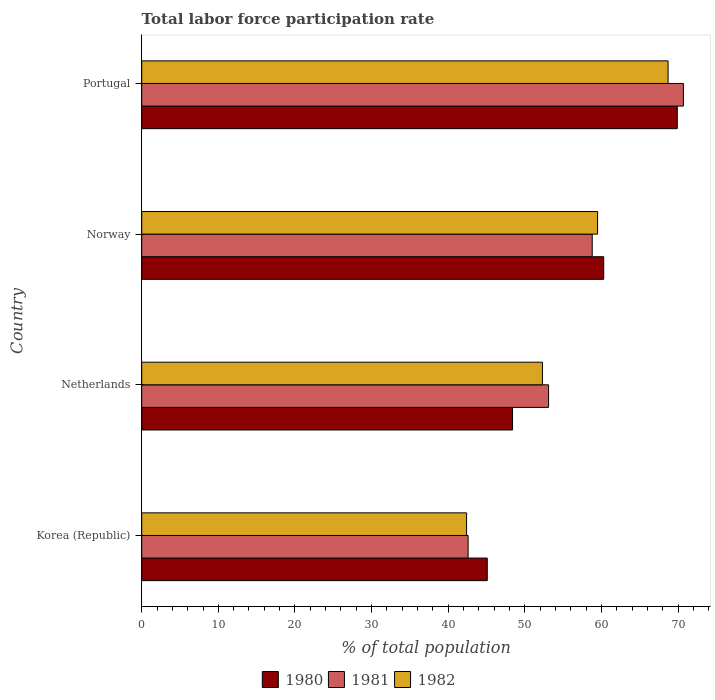Are the number of bars on each tick of the Y-axis equal?
Your answer should be compact. Yes. What is the label of the 4th group of bars from the top?
Your response must be concise. Korea (Republic). In how many cases, is the number of bars for a given country not equal to the number of legend labels?
Your answer should be very brief. 0. What is the total labor force participation rate in 1981 in Korea (Republic)?
Offer a very short reply. 42.6. Across all countries, what is the maximum total labor force participation rate in 1982?
Offer a very short reply. 68.7. Across all countries, what is the minimum total labor force participation rate in 1981?
Ensure brevity in your answer.  42.6. In which country was the total labor force participation rate in 1982 minimum?
Provide a succinct answer. Korea (Republic). What is the total total labor force participation rate in 1980 in the graph?
Your answer should be very brief. 223.7. What is the difference between the total labor force participation rate in 1982 in Norway and that in Portugal?
Keep it short and to the point. -9.2. What is the difference between the total labor force participation rate in 1982 in Netherlands and the total labor force participation rate in 1980 in Norway?
Make the answer very short. -8. What is the average total labor force participation rate in 1981 per country?
Give a very brief answer. 56.3. What is the difference between the total labor force participation rate in 1981 and total labor force participation rate in 1980 in Norway?
Your response must be concise. -1.5. In how many countries, is the total labor force participation rate in 1980 greater than 52 %?
Your response must be concise. 2. What is the ratio of the total labor force participation rate in 1981 in Korea (Republic) to that in Portugal?
Provide a succinct answer. 0.6. Is the total labor force participation rate in 1981 in Korea (Republic) less than that in Portugal?
Your answer should be very brief. Yes. What is the difference between the highest and the second highest total labor force participation rate in 1981?
Offer a very short reply. 11.9. What is the difference between the highest and the lowest total labor force participation rate in 1980?
Keep it short and to the point. 24.8. Is the sum of the total labor force participation rate in 1980 in Netherlands and Norway greater than the maximum total labor force participation rate in 1982 across all countries?
Ensure brevity in your answer.  Yes. Is it the case that in every country, the sum of the total labor force participation rate in 1980 and total labor force participation rate in 1982 is greater than the total labor force participation rate in 1981?
Ensure brevity in your answer.  Yes. How many countries are there in the graph?
Ensure brevity in your answer.  4. What is the difference between two consecutive major ticks on the X-axis?
Provide a short and direct response. 10. Where does the legend appear in the graph?
Give a very brief answer. Bottom center. How many legend labels are there?
Your answer should be very brief. 3. How are the legend labels stacked?
Provide a succinct answer. Horizontal. What is the title of the graph?
Provide a succinct answer. Total labor force participation rate. Does "2013" appear as one of the legend labels in the graph?
Ensure brevity in your answer.  No. What is the label or title of the X-axis?
Your answer should be very brief. % of total population. What is the % of total population in 1980 in Korea (Republic)?
Give a very brief answer. 45.1. What is the % of total population of 1981 in Korea (Republic)?
Your answer should be compact. 42.6. What is the % of total population in 1982 in Korea (Republic)?
Ensure brevity in your answer.  42.4. What is the % of total population in 1980 in Netherlands?
Keep it short and to the point. 48.4. What is the % of total population of 1981 in Netherlands?
Your answer should be very brief. 53.1. What is the % of total population of 1982 in Netherlands?
Your response must be concise. 52.3. What is the % of total population in 1980 in Norway?
Provide a short and direct response. 60.3. What is the % of total population of 1981 in Norway?
Your response must be concise. 58.8. What is the % of total population of 1982 in Norway?
Keep it short and to the point. 59.5. What is the % of total population of 1980 in Portugal?
Make the answer very short. 69.9. What is the % of total population of 1981 in Portugal?
Ensure brevity in your answer.  70.7. What is the % of total population of 1982 in Portugal?
Offer a terse response. 68.7. Across all countries, what is the maximum % of total population of 1980?
Provide a short and direct response. 69.9. Across all countries, what is the maximum % of total population in 1981?
Keep it short and to the point. 70.7. Across all countries, what is the maximum % of total population of 1982?
Keep it short and to the point. 68.7. Across all countries, what is the minimum % of total population of 1980?
Ensure brevity in your answer.  45.1. Across all countries, what is the minimum % of total population of 1981?
Offer a very short reply. 42.6. Across all countries, what is the minimum % of total population of 1982?
Ensure brevity in your answer.  42.4. What is the total % of total population of 1980 in the graph?
Your answer should be compact. 223.7. What is the total % of total population in 1981 in the graph?
Your answer should be very brief. 225.2. What is the total % of total population of 1982 in the graph?
Provide a succinct answer. 222.9. What is the difference between the % of total population in 1980 in Korea (Republic) and that in Netherlands?
Your answer should be compact. -3.3. What is the difference between the % of total population of 1981 in Korea (Republic) and that in Netherlands?
Keep it short and to the point. -10.5. What is the difference between the % of total population in 1982 in Korea (Republic) and that in Netherlands?
Give a very brief answer. -9.9. What is the difference between the % of total population of 1980 in Korea (Republic) and that in Norway?
Make the answer very short. -15.2. What is the difference between the % of total population in 1981 in Korea (Republic) and that in Norway?
Keep it short and to the point. -16.2. What is the difference between the % of total population in 1982 in Korea (Republic) and that in Norway?
Give a very brief answer. -17.1. What is the difference between the % of total population in 1980 in Korea (Republic) and that in Portugal?
Ensure brevity in your answer.  -24.8. What is the difference between the % of total population in 1981 in Korea (Republic) and that in Portugal?
Give a very brief answer. -28.1. What is the difference between the % of total population in 1982 in Korea (Republic) and that in Portugal?
Make the answer very short. -26.3. What is the difference between the % of total population of 1980 in Netherlands and that in Portugal?
Provide a short and direct response. -21.5. What is the difference between the % of total population of 1981 in Netherlands and that in Portugal?
Provide a short and direct response. -17.6. What is the difference between the % of total population in 1982 in Netherlands and that in Portugal?
Provide a short and direct response. -16.4. What is the difference between the % of total population of 1981 in Norway and that in Portugal?
Keep it short and to the point. -11.9. What is the difference between the % of total population of 1982 in Norway and that in Portugal?
Make the answer very short. -9.2. What is the difference between the % of total population in 1980 in Korea (Republic) and the % of total population in 1981 in Netherlands?
Your response must be concise. -8. What is the difference between the % of total population of 1980 in Korea (Republic) and the % of total population of 1981 in Norway?
Your answer should be very brief. -13.7. What is the difference between the % of total population in 1980 in Korea (Republic) and the % of total population in 1982 in Norway?
Provide a short and direct response. -14.4. What is the difference between the % of total population of 1981 in Korea (Republic) and the % of total population of 1982 in Norway?
Offer a very short reply. -16.9. What is the difference between the % of total population of 1980 in Korea (Republic) and the % of total population of 1981 in Portugal?
Give a very brief answer. -25.6. What is the difference between the % of total population in 1980 in Korea (Republic) and the % of total population in 1982 in Portugal?
Make the answer very short. -23.6. What is the difference between the % of total population in 1981 in Korea (Republic) and the % of total population in 1982 in Portugal?
Keep it short and to the point. -26.1. What is the difference between the % of total population of 1981 in Netherlands and the % of total population of 1982 in Norway?
Offer a very short reply. -6.4. What is the difference between the % of total population of 1980 in Netherlands and the % of total population of 1981 in Portugal?
Provide a short and direct response. -22.3. What is the difference between the % of total population of 1980 in Netherlands and the % of total population of 1982 in Portugal?
Offer a terse response. -20.3. What is the difference between the % of total population in 1981 in Netherlands and the % of total population in 1982 in Portugal?
Keep it short and to the point. -15.6. What is the difference between the % of total population in 1980 in Norway and the % of total population in 1982 in Portugal?
Give a very brief answer. -8.4. What is the difference between the % of total population of 1981 in Norway and the % of total population of 1982 in Portugal?
Keep it short and to the point. -9.9. What is the average % of total population of 1980 per country?
Give a very brief answer. 55.92. What is the average % of total population in 1981 per country?
Your answer should be very brief. 56.3. What is the average % of total population of 1982 per country?
Your answer should be compact. 55.73. What is the difference between the % of total population of 1980 and % of total population of 1981 in Netherlands?
Keep it short and to the point. -4.7. What is the difference between the % of total population of 1981 and % of total population of 1982 in Netherlands?
Keep it short and to the point. 0.8. What is the difference between the % of total population in 1980 and % of total population in 1982 in Norway?
Give a very brief answer. 0.8. What is the difference between the % of total population of 1981 and % of total population of 1982 in Portugal?
Ensure brevity in your answer.  2. What is the ratio of the % of total population in 1980 in Korea (Republic) to that in Netherlands?
Make the answer very short. 0.93. What is the ratio of the % of total population of 1981 in Korea (Republic) to that in Netherlands?
Your response must be concise. 0.8. What is the ratio of the % of total population of 1982 in Korea (Republic) to that in Netherlands?
Provide a succinct answer. 0.81. What is the ratio of the % of total population of 1980 in Korea (Republic) to that in Norway?
Provide a short and direct response. 0.75. What is the ratio of the % of total population in 1981 in Korea (Republic) to that in Norway?
Your answer should be very brief. 0.72. What is the ratio of the % of total population of 1982 in Korea (Republic) to that in Norway?
Your answer should be compact. 0.71. What is the ratio of the % of total population of 1980 in Korea (Republic) to that in Portugal?
Offer a very short reply. 0.65. What is the ratio of the % of total population of 1981 in Korea (Republic) to that in Portugal?
Your answer should be very brief. 0.6. What is the ratio of the % of total population of 1982 in Korea (Republic) to that in Portugal?
Provide a short and direct response. 0.62. What is the ratio of the % of total population in 1980 in Netherlands to that in Norway?
Keep it short and to the point. 0.8. What is the ratio of the % of total population in 1981 in Netherlands to that in Norway?
Your answer should be compact. 0.9. What is the ratio of the % of total population in 1982 in Netherlands to that in Norway?
Offer a very short reply. 0.88. What is the ratio of the % of total population in 1980 in Netherlands to that in Portugal?
Keep it short and to the point. 0.69. What is the ratio of the % of total population in 1981 in Netherlands to that in Portugal?
Your response must be concise. 0.75. What is the ratio of the % of total population in 1982 in Netherlands to that in Portugal?
Your answer should be compact. 0.76. What is the ratio of the % of total population of 1980 in Norway to that in Portugal?
Provide a succinct answer. 0.86. What is the ratio of the % of total population in 1981 in Norway to that in Portugal?
Give a very brief answer. 0.83. What is the ratio of the % of total population in 1982 in Norway to that in Portugal?
Your answer should be very brief. 0.87. What is the difference between the highest and the second highest % of total population of 1980?
Your answer should be compact. 9.6. What is the difference between the highest and the second highest % of total population in 1981?
Offer a very short reply. 11.9. What is the difference between the highest and the second highest % of total population in 1982?
Provide a short and direct response. 9.2. What is the difference between the highest and the lowest % of total population in 1980?
Your answer should be compact. 24.8. What is the difference between the highest and the lowest % of total population in 1981?
Keep it short and to the point. 28.1. What is the difference between the highest and the lowest % of total population in 1982?
Offer a very short reply. 26.3. 